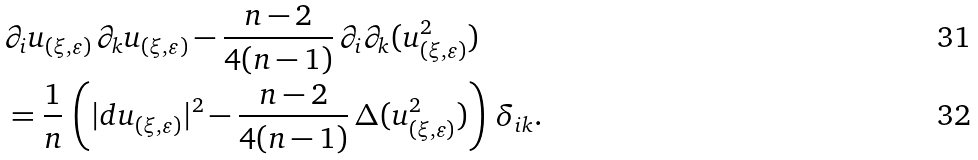<formula> <loc_0><loc_0><loc_500><loc_500>& \partial _ { i } u _ { ( \xi , \varepsilon ) } \, \partial _ { k } u _ { ( \xi , \varepsilon ) } - \frac { n - 2 } { 4 ( n - 1 ) } \, \partial _ { i } \partial _ { k } ( u _ { ( \xi , \varepsilon ) } ^ { 2 } ) \\ & = \frac { 1 } { n } \, \left ( | d u _ { ( \xi , \varepsilon ) } | ^ { 2 } - \frac { n - 2 } { 4 ( n - 1 ) } \, \Delta ( u _ { ( \xi , \varepsilon ) } ^ { 2 } ) \right ) \, \delta _ { i k } .</formula> 